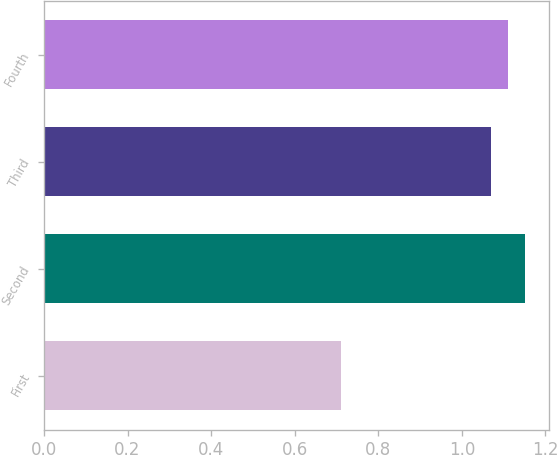Convert chart to OTSL. <chart><loc_0><loc_0><loc_500><loc_500><bar_chart><fcel>First<fcel>Second<fcel>Third<fcel>Fourth<nl><fcel>0.71<fcel>1.15<fcel>1.07<fcel>1.11<nl></chart> 